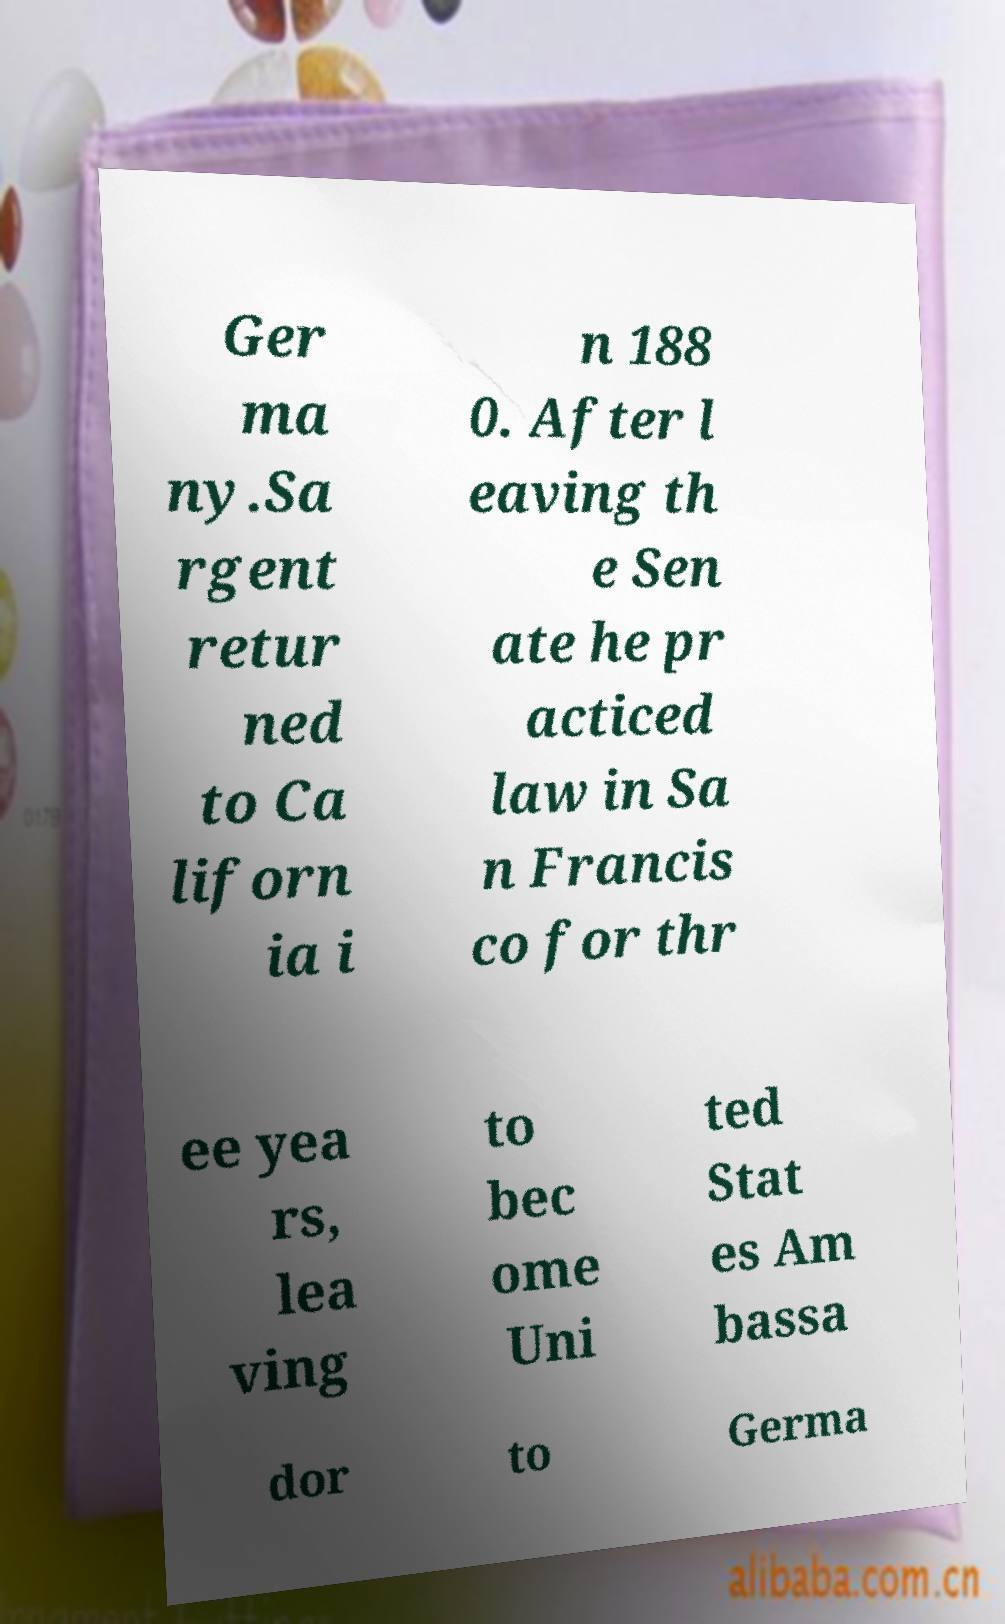Can you read and provide the text displayed in the image?This photo seems to have some interesting text. Can you extract and type it out for me? Ger ma ny.Sa rgent retur ned to Ca liforn ia i n 188 0. After l eaving th e Sen ate he pr acticed law in Sa n Francis co for thr ee yea rs, lea ving to bec ome Uni ted Stat es Am bassa dor to Germa 